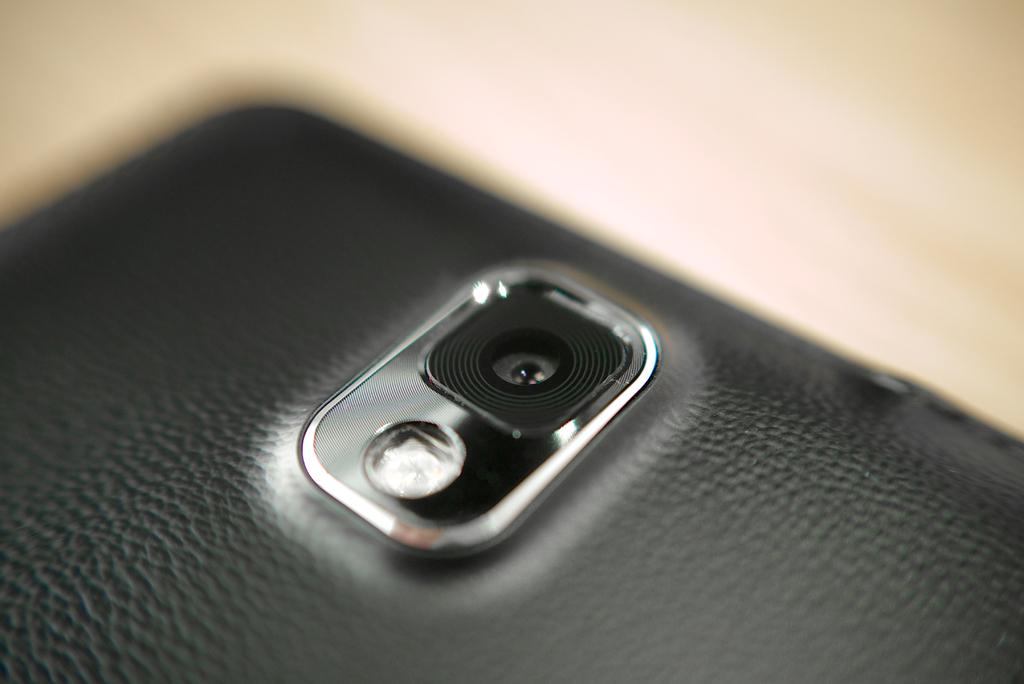What electronic device is visible in the image? There is a smartphone in the image. What type of belief is represented by the smartphone in the image? The smartphone does not represent any belief; it is an electronic device. What part of the body is shown interacting with the smartphone in the image? There is no part of the body visible in the image, as it only shows the smartphone. 